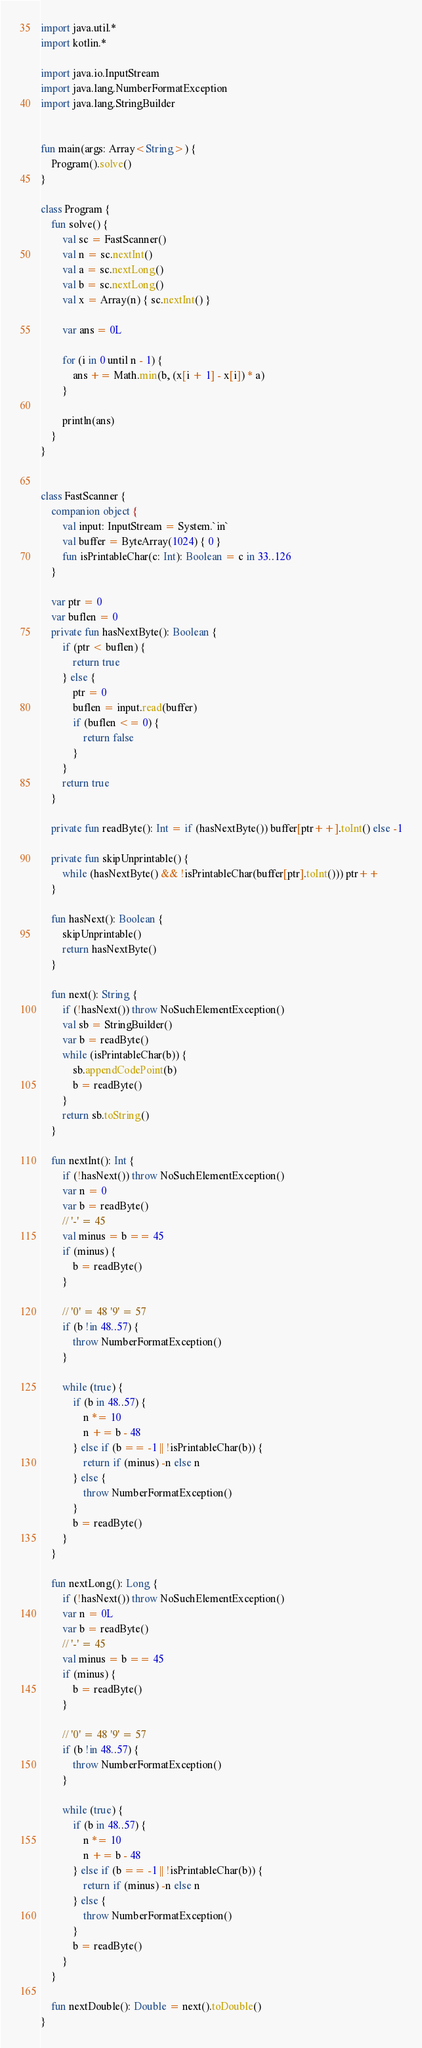<code> <loc_0><loc_0><loc_500><loc_500><_Kotlin_>import java.util.*
import kotlin.*

import java.io.InputStream
import java.lang.NumberFormatException
import java.lang.StringBuilder


fun main(args: Array<String>) {
    Program().solve()
}

class Program {
    fun solve() {
        val sc = FastScanner()
        val n = sc.nextInt()
        val a = sc.nextLong()
        val b = sc.nextLong()
        val x = Array(n) { sc.nextInt() }
        
        var ans = 0L

        for (i in 0 until n - 1) {
            ans += Math.min(b, (x[i + 1] - x[i]) * a)
        }

        println(ans)
    }
}


class FastScanner {
    companion object {
        val input: InputStream = System.`in`
        val buffer = ByteArray(1024) { 0 }
        fun isPrintableChar(c: Int): Boolean = c in 33..126
    }

    var ptr = 0
    var buflen = 0
    private fun hasNextByte(): Boolean {
        if (ptr < buflen) {
            return true
        } else {
            ptr = 0
            buflen = input.read(buffer)
            if (buflen <= 0) {
                return false
            }
        }
        return true
    }

    private fun readByte(): Int = if (hasNextByte()) buffer[ptr++].toInt() else -1

    private fun skipUnprintable() {
        while (hasNextByte() && !isPrintableChar(buffer[ptr].toInt())) ptr++
    }

    fun hasNext(): Boolean {
        skipUnprintable()
        return hasNextByte()
    }

    fun next(): String {
        if (!hasNext()) throw NoSuchElementException()
        val sb = StringBuilder()
        var b = readByte()
        while (isPrintableChar(b)) {
            sb.appendCodePoint(b)
            b = readByte()
        }
        return sb.toString()
    }

    fun nextInt(): Int {
        if (!hasNext()) throw NoSuchElementException()
        var n = 0
        var b = readByte()
        // '-' = 45
        val minus = b == 45
        if (minus) {
            b = readByte()
        }

        // '0' = 48 '9' = 57
        if (b !in 48..57) {
            throw NumberFormatException()
        }

        while (true) {
            if (b in 48..57) {
                n *= 10
                n += b - 48
            } else if (b == -1 || !isPrintableChar(b)) {
                return if (minus) -n else n
            } else {
                throw NumberFormatException()
            }
            b = readByte()
        }
    }

    fun nextLong(): Long {
        if (!hasNext()) throw NoSuchElementException()
        var n = 0L
        var b = readByte()
        // '-' = 45
        val minus = b == 45
        if (minus) {
            b = readByte()
        }

        // '0' = 48 '9' = 57
        if (b !in 48..57) {
            throw NumberFormatException()
        }

        while (true) {
            if (b in 48..57) {
                n *= 10
                n += b - 48
            } else if (b == -1 || !isPrintableChar(b)) {
                return if (minus) -n else n
            } else {
                throw NumberFormatException()
            }
            b = readByte()
        }
    }

    fun nextDouble(): Double = next().toDouble()
}
</code> 